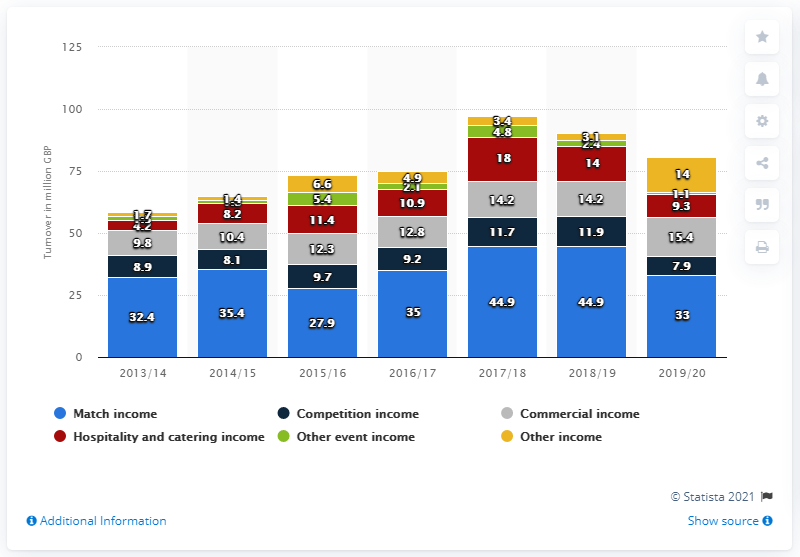Outline some significant characteristics in this image. In 2015/16, the total income was 73.3 million. The year with the least turnover in competition income was 2019/2020. 